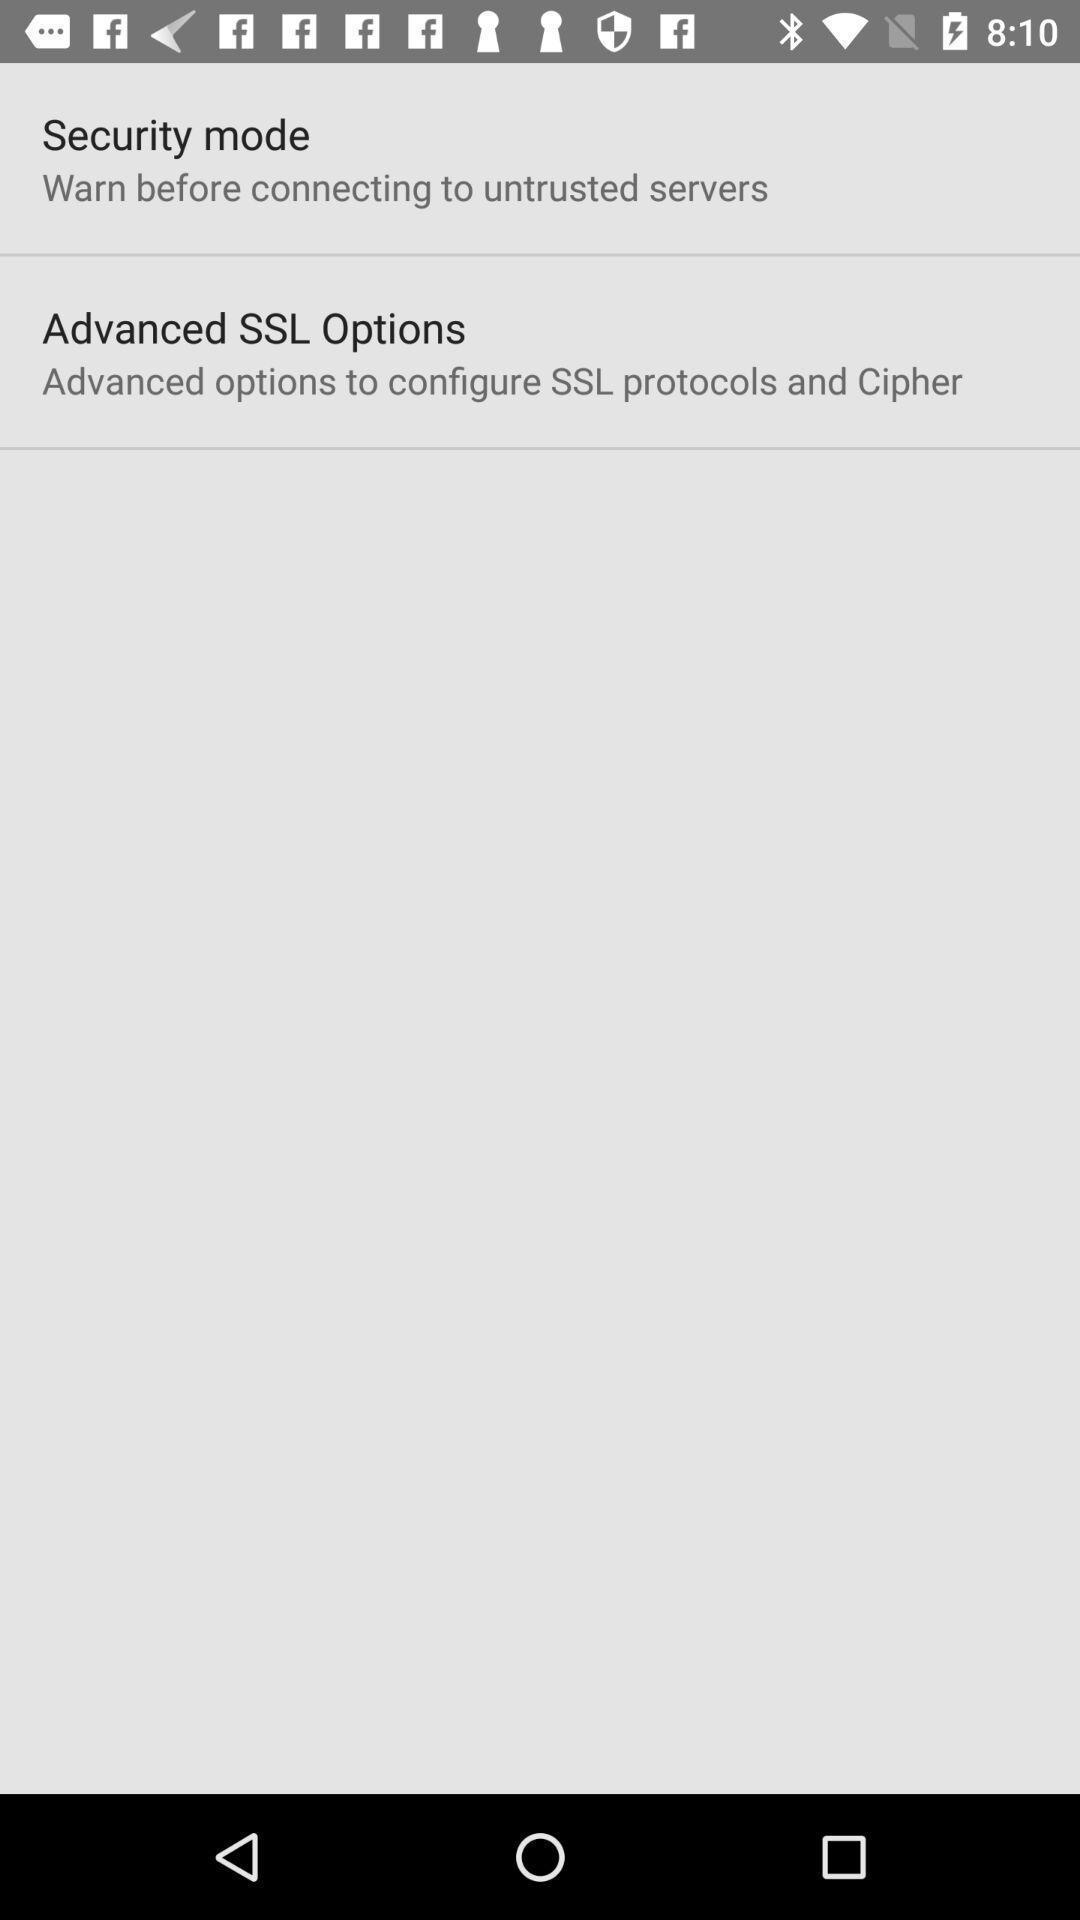Tell me what you see in this picture. Screen showing options. 